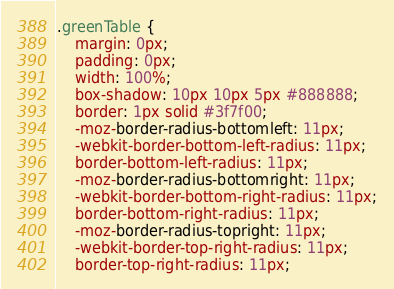Convert code to text. <code><loc_0><loc_0><loc_500><loc_500><_CSS_>.greenTable {
	margin: 0px;
	padding: 0px;
	width: 100%;
	box-shadow: 10px 10px 5px #888888;
	border: 1px solid #3f7f00;
	-moz-border-radius-bottomleft: 11px;
	-webkit-border-bottom-left-radius: 11px;
	border-bottom-left-radius: 11px;
	-moz-border-radius-bottomright: 11px;
	-webkit-border-bottom-right-radius: 11px;
	border-bottom-right-radius: 11px;
	-moz-border-radius-topright: 11px;
	-webkit-border-top-right-radius: 11px;
	border-top-right-radius: 11px;</code> 